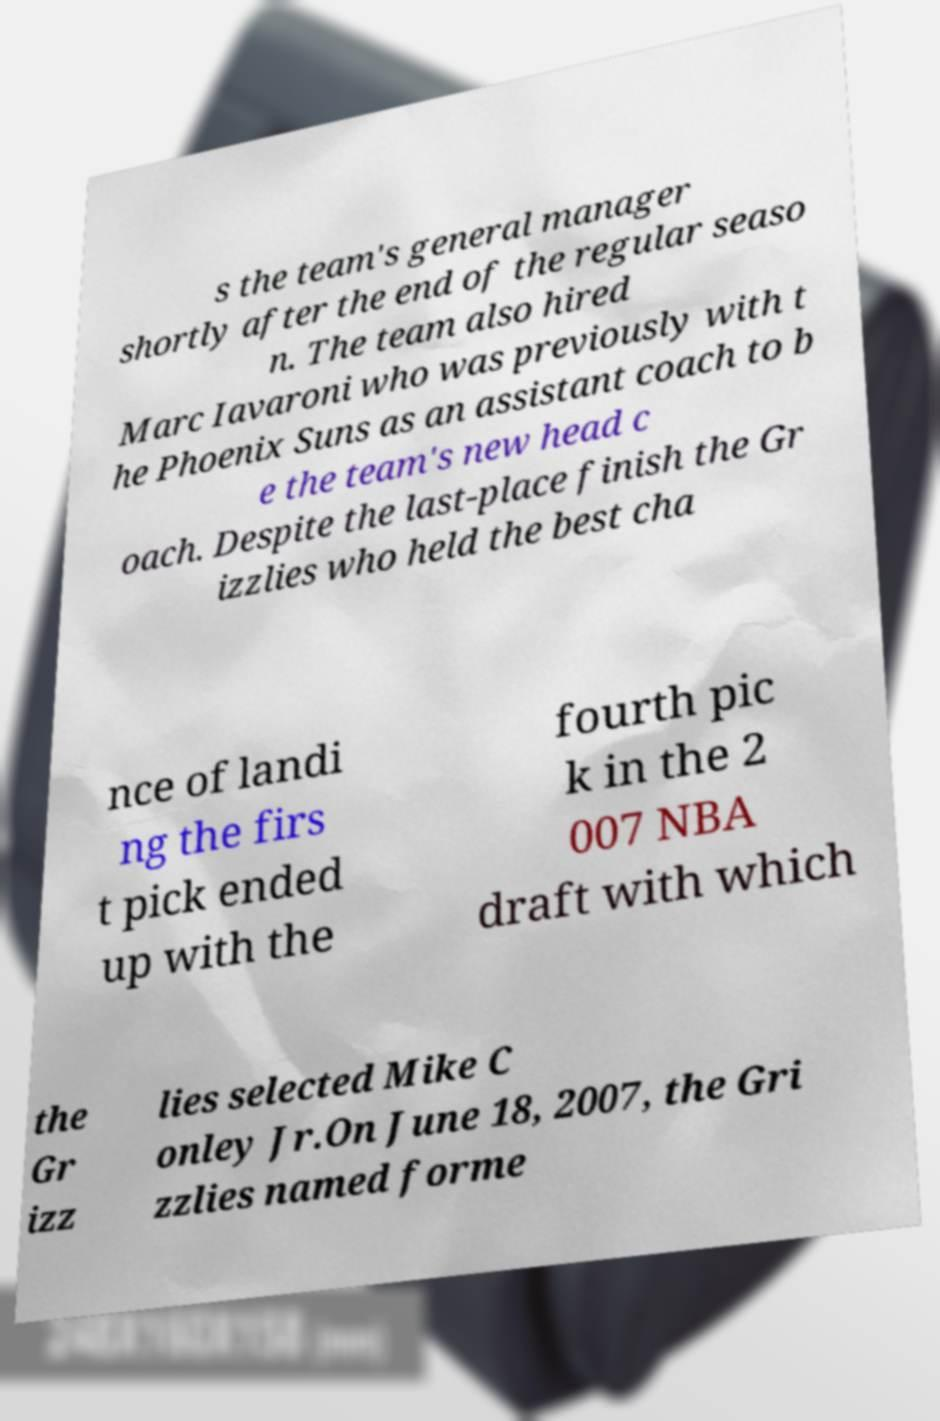Please identify and transcribe the text found in this image. s the team's general manager shortly after the end of the regular seaso n. The team also hired Marc Iavaroni who was previously with t he Phoenix Suns as an assistant coach to b e the team's new head c oach. Despite the last-place finish the Gr izzlies who held the best cha nce of landi ng the firs t pick ended up with the fourth pic k in the 2 007 NBA draft with which the Gr izz lies selected Mike C onley Jr.On June 18, 2007, the Gri zzlies named forme 